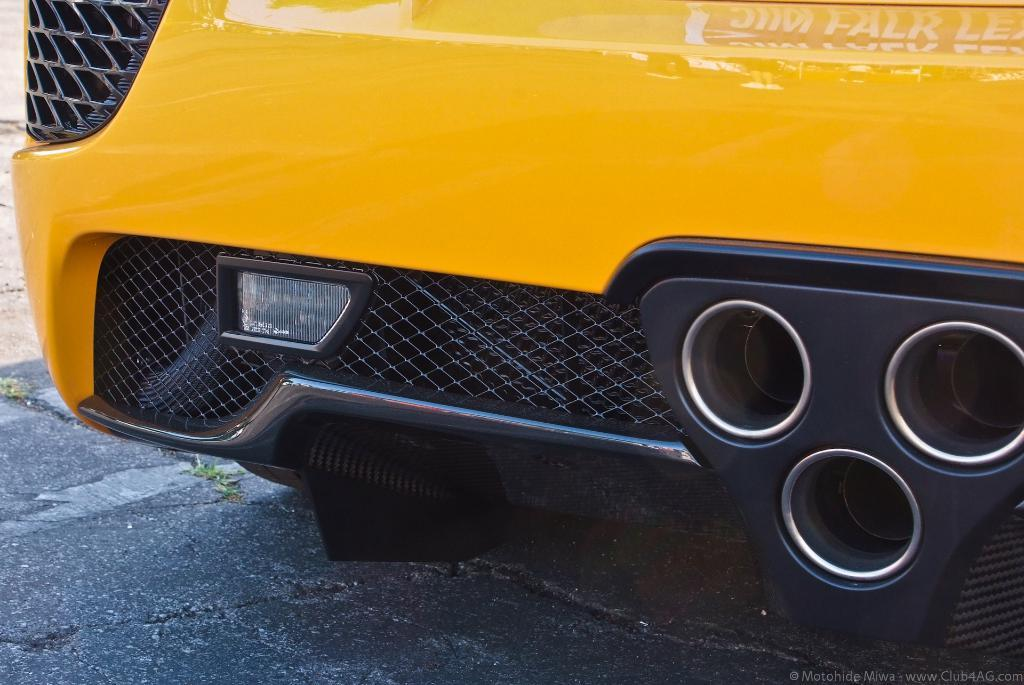What is the main subject of the image? There is a vehicle on the road in the image. Can you describe any additional features of the image? There is a watermark on the image. What day of the week is depicted on the calendar in the image? There is no calendar present in the image. What type of plants can be seen in the garden in the image? There is no garden present in the image. 